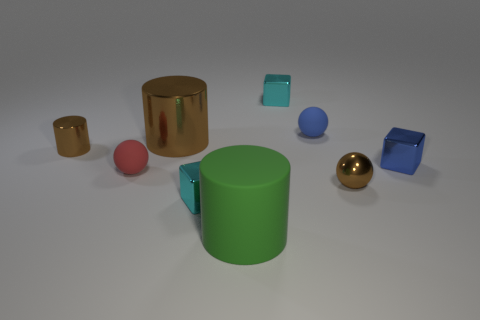What is the material of the brown cylinder that is the same size as the red ball? The brown cylinder appears to have a reflective surface which suggests it could be made of a polished metal, such as bronze or copper, providing it with a shiny finish that mimics the appearance of some metals. 